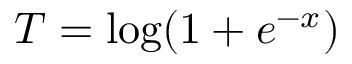Convert formula to latex. <formula><loc_0><loc_0><loc_500><loc_500>T = \log ( 1 + e ^ { - x } )</formula> 